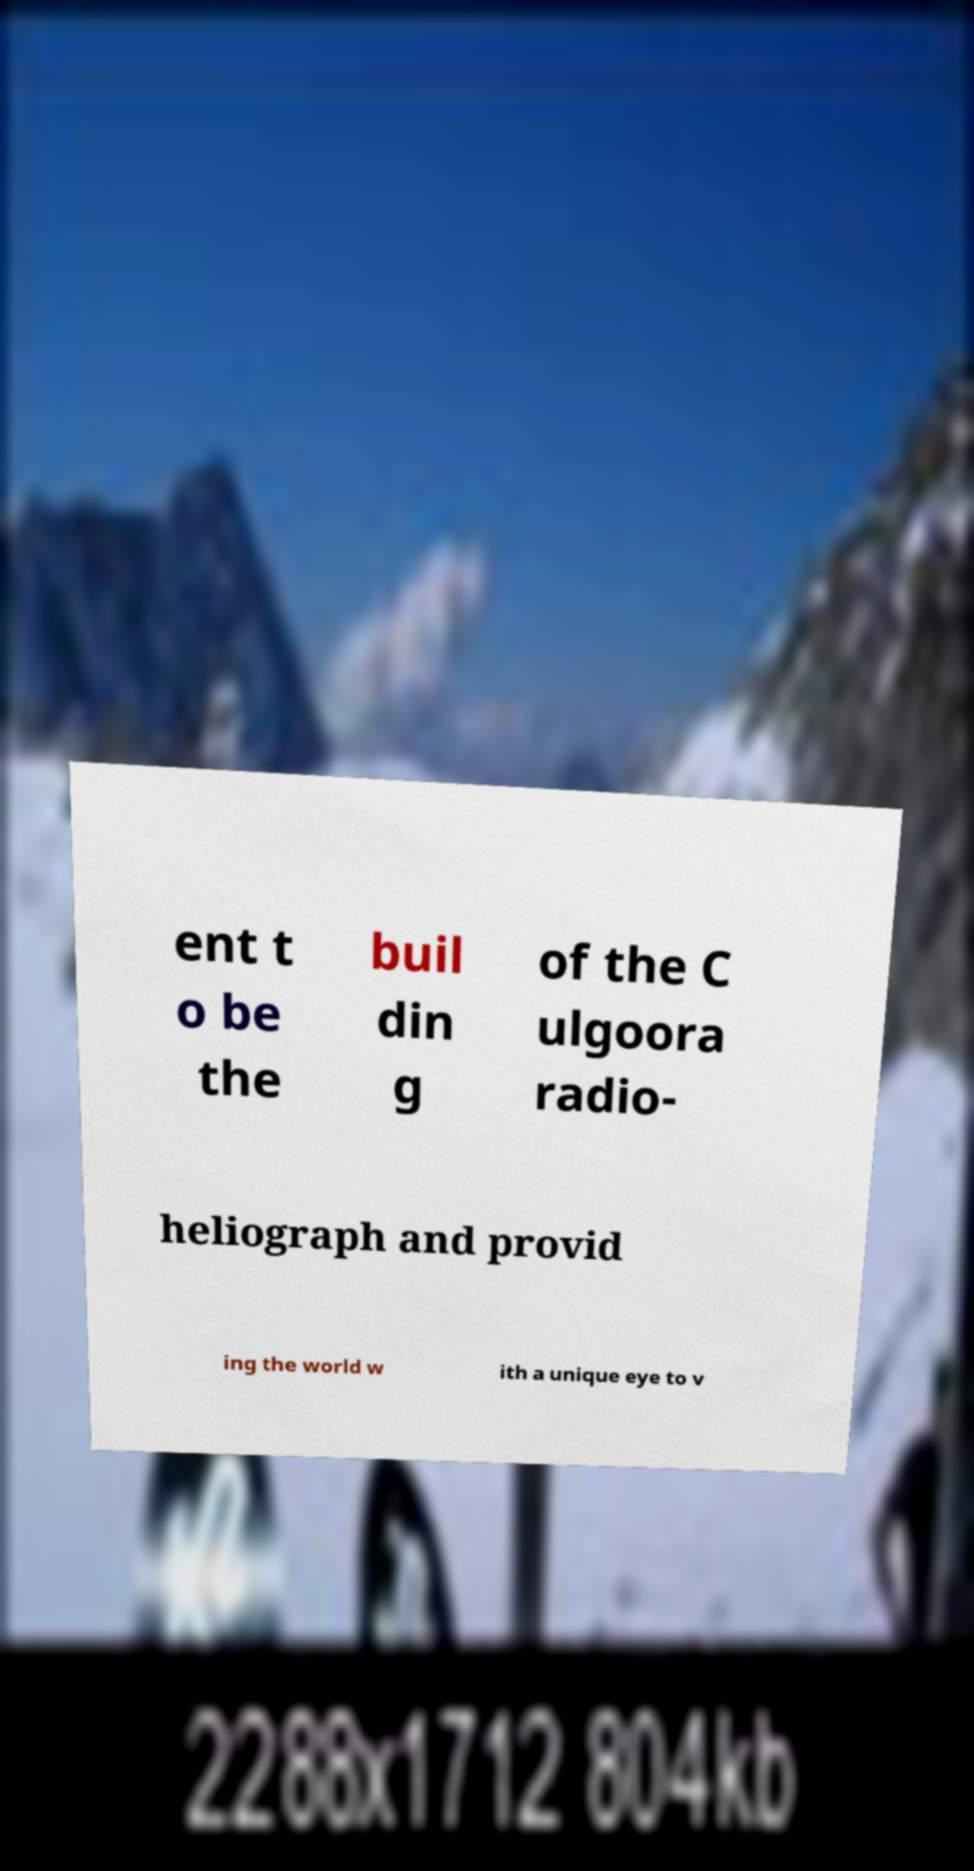What messages or text are displayed in this image? I need them in a readable, typed format. ent t o be the buil din g of the C ulgoora radio- heliograph and provid ing the world w ith a unique eye to v 